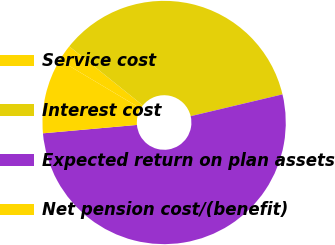Convert chart to OTSL. <chart><loc_0><loc_0><loc_500><loc_500><pie_chart><fcel>Service cost<fcel>Interest cost<fcel>Expected return on plan assets<fcel>Net pension cost/(benefit)<nl><fcel>2.2%<fcel>35.53%<fcel>52.3%<fcel>9.98%<nl></chart> 